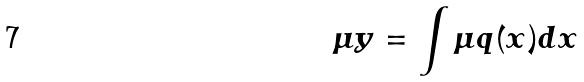Convert formula to latex. <formula><loc_0><loc_0><loc_500><loc_500>\mu y = \int \mu q ( x ) d x</formula> 